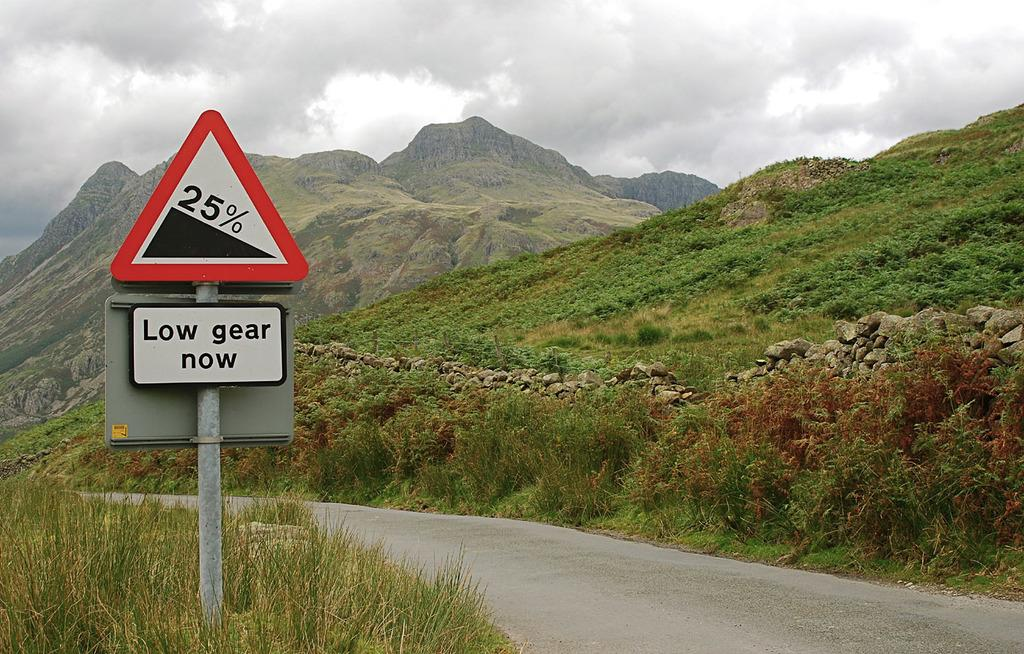What type of vegetation is present in the image? There is grass in the image. What other objects can be seen in the image? There are stones and a sign pole visible in the image. What type of landscape feature is present in the image? There are hills in the image. What is visible at the top of the image? The sky is visible at the top of the image. Can you tell me what type of fiction the doctor is reading in the image? There is no doctor or fiction present in the image. How many bees can be seen buzzing around the sign pole in the image? There are no bees present in the image. 